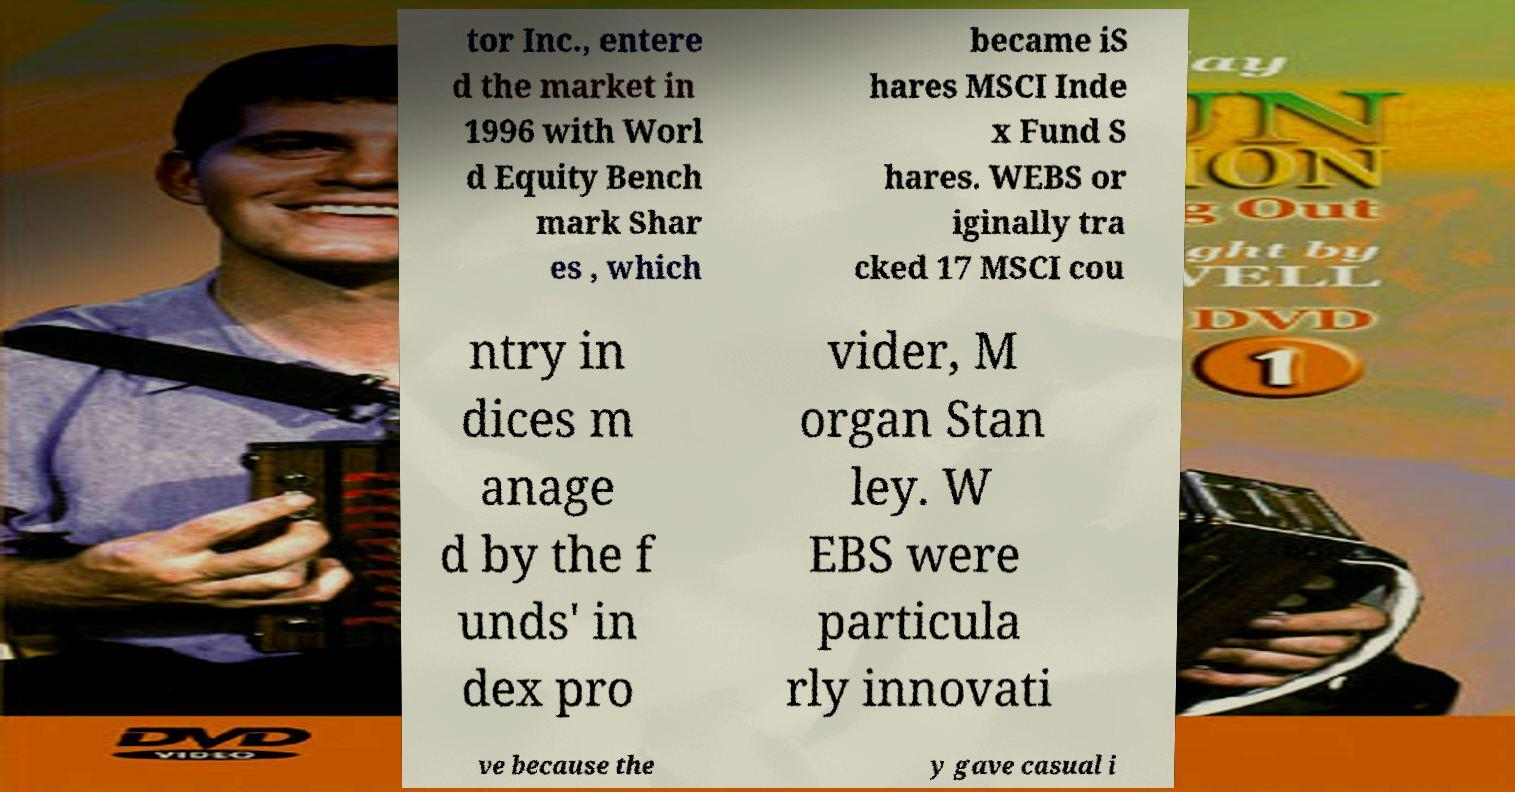I need the written content from this picture converted into text. Can you do that? tor Inc., entere d the market in 1996 with Worl d Equity Bench mark Shar es , which became iS hares MSCI Inde x Fund S hares. WEBS or iginally tra cked 17 MSCI cou ntry in dices m anage d by the f unds' in dex pro vider, M organ Stan ley. W EBS were particula rly innovati ve because the y gave casual i 